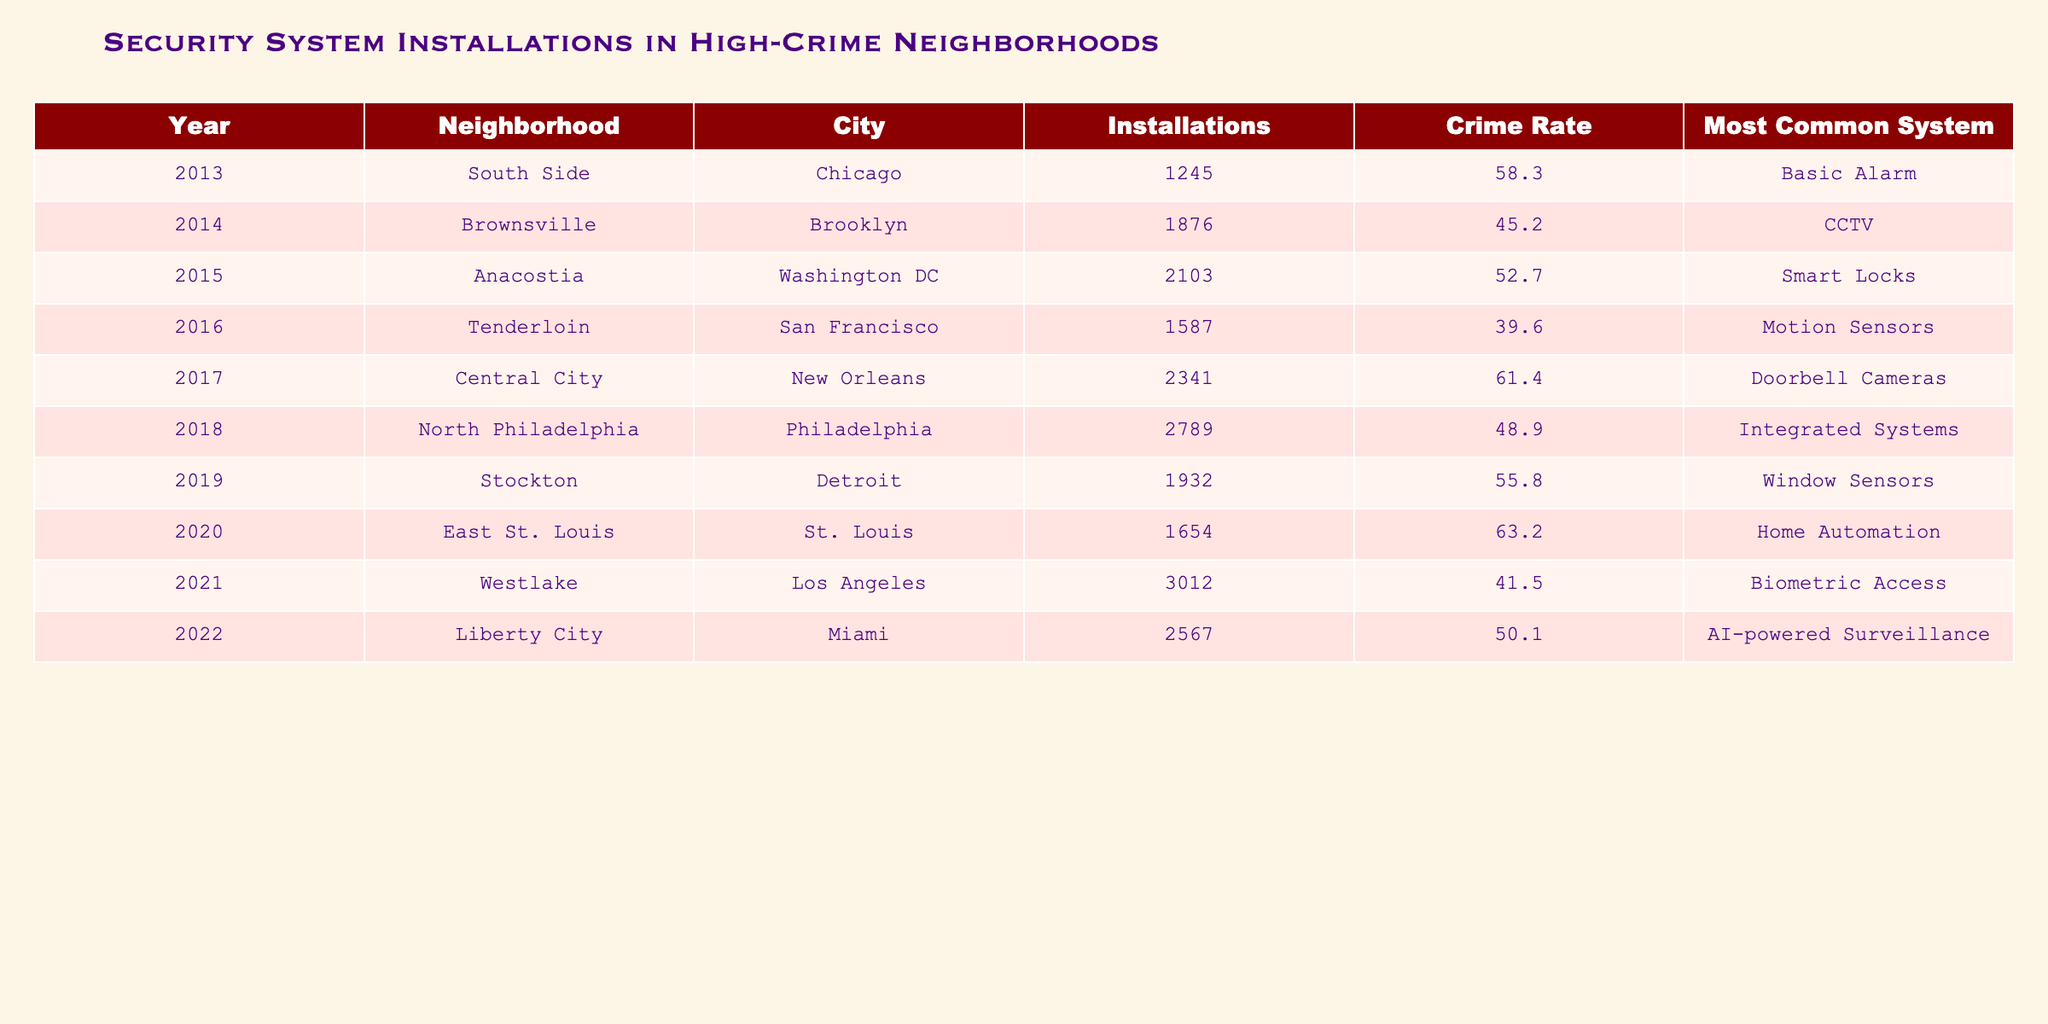What was the crime rate in Brownsville, Brooklyn in 2014? The crime rate for Brownsville, Brooklyn in 2014 is specifically listed in the table as 45.2.
Answer: 45.2 Which neighborhood had the highest number of security system installations in 2021? According to the table, Westlake, Los Angeles had the highest number of installations in 2021 with 3012 installations.
Answer: Westlake, Los Angeles What is the average number of installations from 2013 to 2018? To find the average, first sum the number of installations from 2013 to 2018: (1245 + 1876 + 2103 + 1587 + 2341 + 2789) = 10941. Then divide by the number of years, which is 6: 10941 / 6 = 1823.5.
Answer: 1823.5 Was there an increase or decrease in installations from 2015 to 2016? For 2015, the number of installations is 2103 and for 2016, it is 1587. Since 1587 is less than 2103, there was a decrease.
Answer: Decrease What system was most commonly installed in neighborhoods with a crime rate greater than 60? The neighborhoods with a crime rate greater than 60 are Central City, New Orleans (61.4) and East St. Louis, St. Louis (63.2). The most common systems for those years were Doorbell Cameras and Home Automation, respectively.
Answer: Doorbell Cameras and Home Automation What was the difference in crime rate between 2019 and 2022? The crime rates for 2019 and 2022 are 55.8 and 50.1, respectively. The difference is calculated as 55.8 - 50.1 = 5.7.
Answer: 5.7 Which city had the highest crime rate in 2017? The crime rate for Central City, New Orleans in 2017 is noted as 61.4, which is the highest in the table for that year.
Answer: Central City, New Orleans What can be inferred about the trend in installations between 2013 and 2022? By observing the installation numbers for every year, it shows a general upward trend from 1245 installations in 2013 to 2567 in 2022, indicating an increasing interest in security systems over time in high-crime neighborhoods.
Answer: Increasing trend Which system had the least installations in neighborhoods below a crime rate of 50 in 2018? In 2018, the crime rate for North Philadelphia was 48.9 and the most common system was Integrated Systems, which had 2789 installations. However, there were no neighborhoods below 50 in that year.
Answer: Integrated Systems 